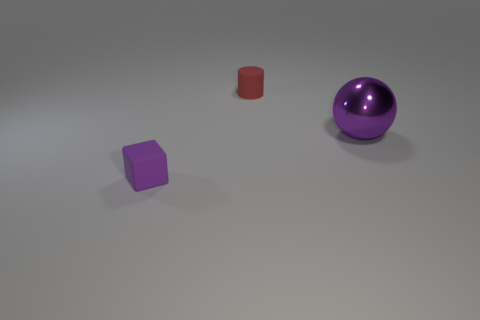Is the size of the rubber object that is in front of the purple sphere the same as the matte cylinder?
Your answer should be compact. Yes. How many objects are either small matte objects to the right of the tiny purple thing or rubber blocks?
Offer a terse response. 2. Is there a red cylinder of the same size as the metallic object?
Offer a very short reply. No. There is a thing that is the same size as the purple cube; what is it made of?
Keep it short and to the point. Rubber. What is the shape of the thing that is both to the left of the big purple metallic sphere and in front of the cylinder?
Provide a short and direct response. Cube. The tiny object behind the tiny rubber block is what color?
Ensure brevity in your answer.  Red. There is a thing that is both to the left of the ball and behind the purple block; what size is it?
Your answer should be very brief. Small. Do the sphere and the tiny object that is in front of the tiny rubber cylinder have the same material?
Offer a terse response. No. What number of small red matte objects have the same shape as the big purple metal thing?
Provide a succinct answer. 0. What material is the cube that is the same color as the large sphere?
Offer a very short reply. Rubber. 